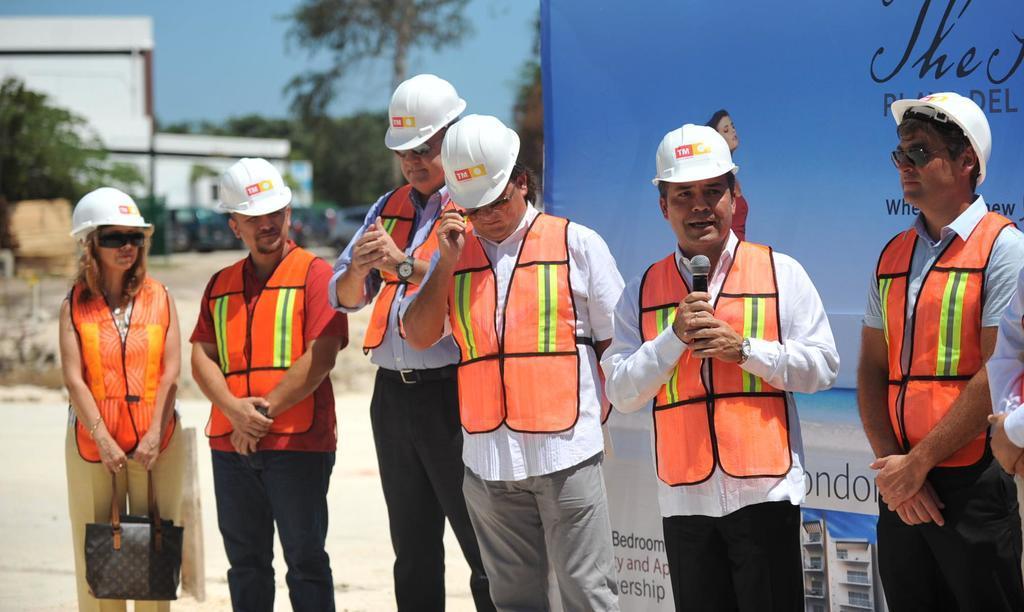Please provide a concise description of this image. As we can see in the image there are group of people over here, banner, trees and a building. On the top there is a sky. 